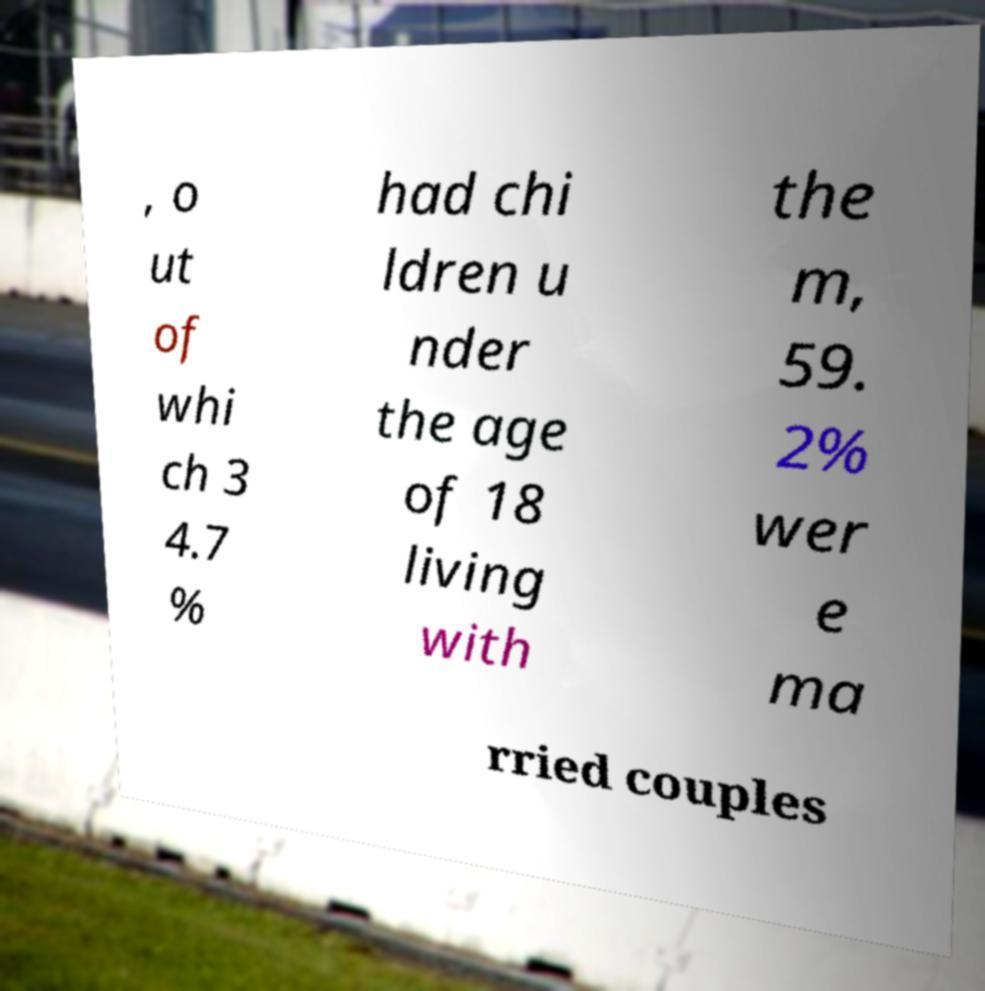Please read and relay the text visible in this image. What does it say? , o ut of whi ch 3 4.7 % had chi ldren u nder the age of 18 living with the m, 59. 2% wer e ma rried couples 